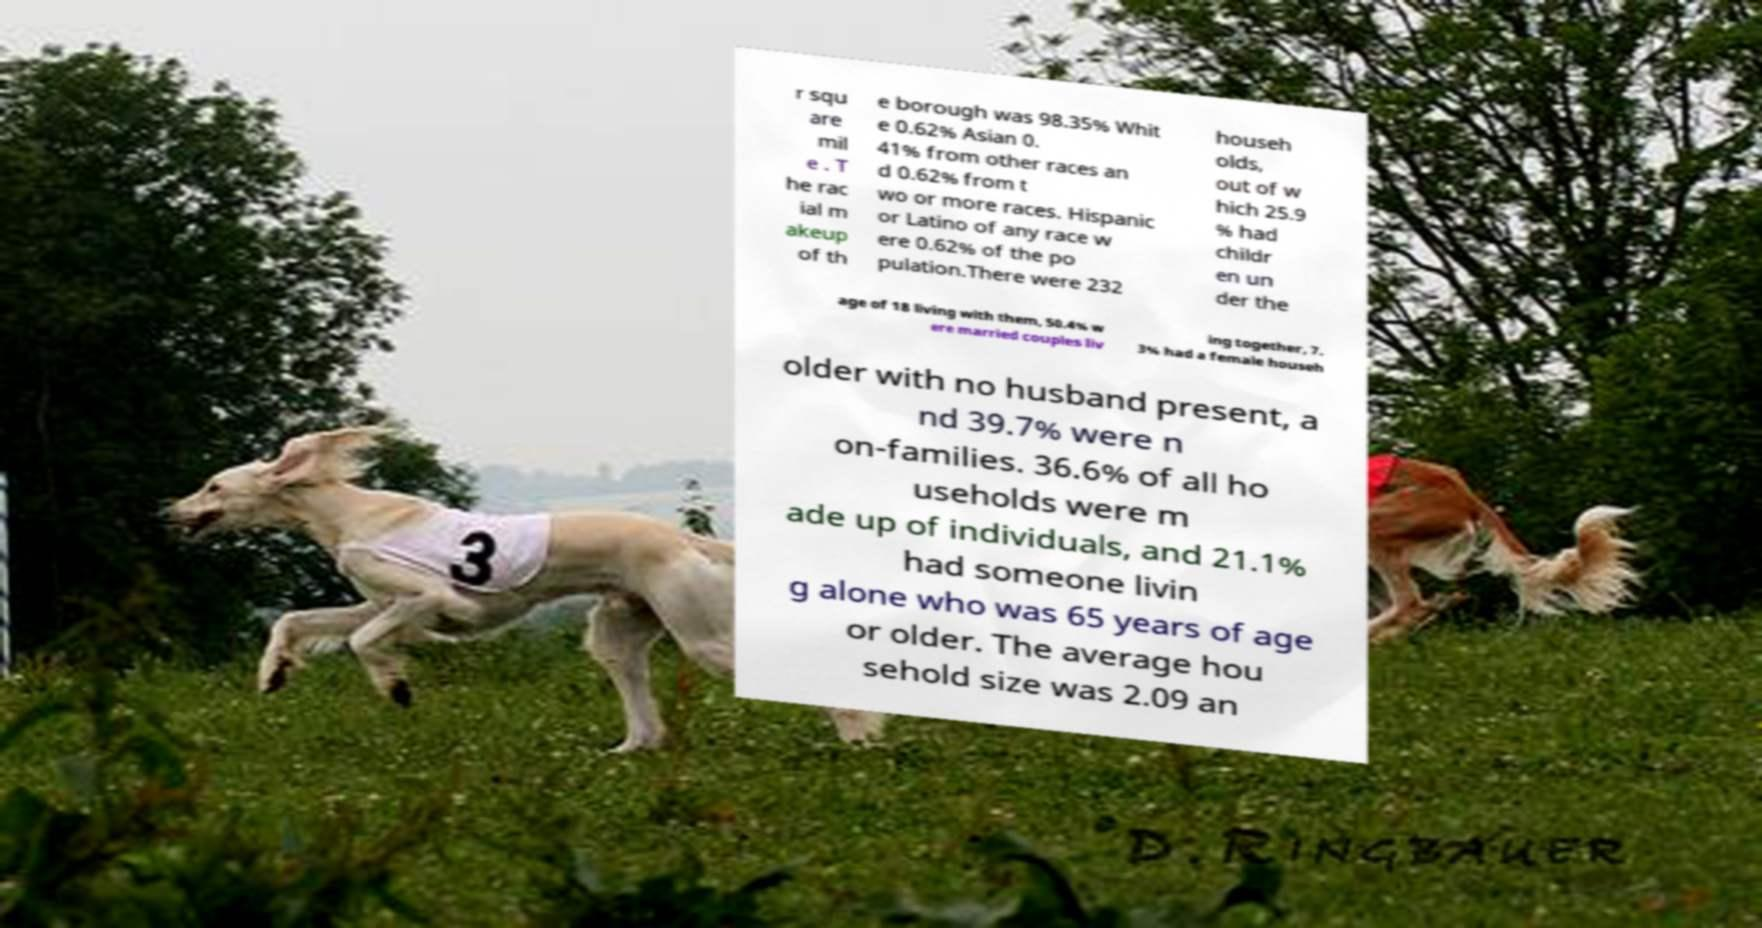Could you assist in decoding the text presented in this image and type it out clearly? r squ are mil e . T he rac ial m akeup of th e borough was 98.35% Whit e 0.62% Asian 0. 41% from other races an d 0.62% from t wo or more races. Hispanic or Latino of any race w ere 0.62% of the po pulation.There were 232 househ olds, out of w hich 25.9 % had childr en un der the age of 18 living with them, 50.4% w ere married couples liv ing together, 7. 3% had a female househ older with no husband present, a nd 39.7% were n on-families. 36.6% of all ho useholds were m ade up of individuals, and 21.1% had someone livin g alone who was 65 years of age or older. The average hou sehold size was 2.09 an 